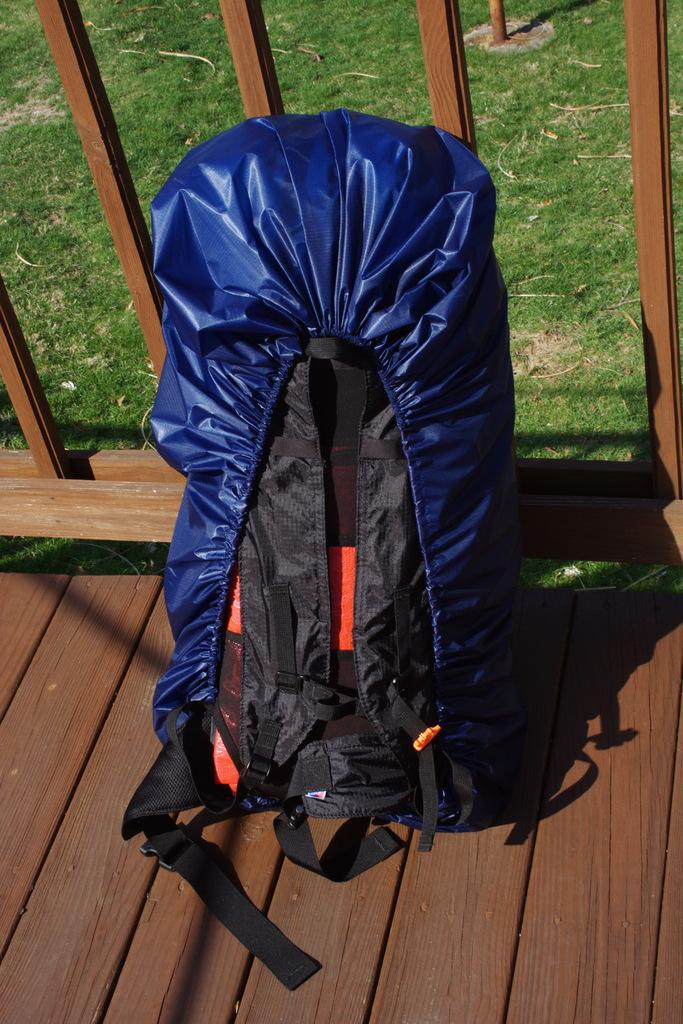What object can be seen in the image that people might use for carrying belongings? There is a backpack in the image that people might use for carrying belongings. What color is the backpack? The backpack is blue. What type of natural environment is visible in the image? There is fresh green grass in the image. What structure can be seen in the image that might serve as a boundary or barrier? There is a fence in the image. What type of afterthought can be seen coiled around the fence in the image? There is no afterthought or coil present in the image; the facts provided do not mention any such objects. 